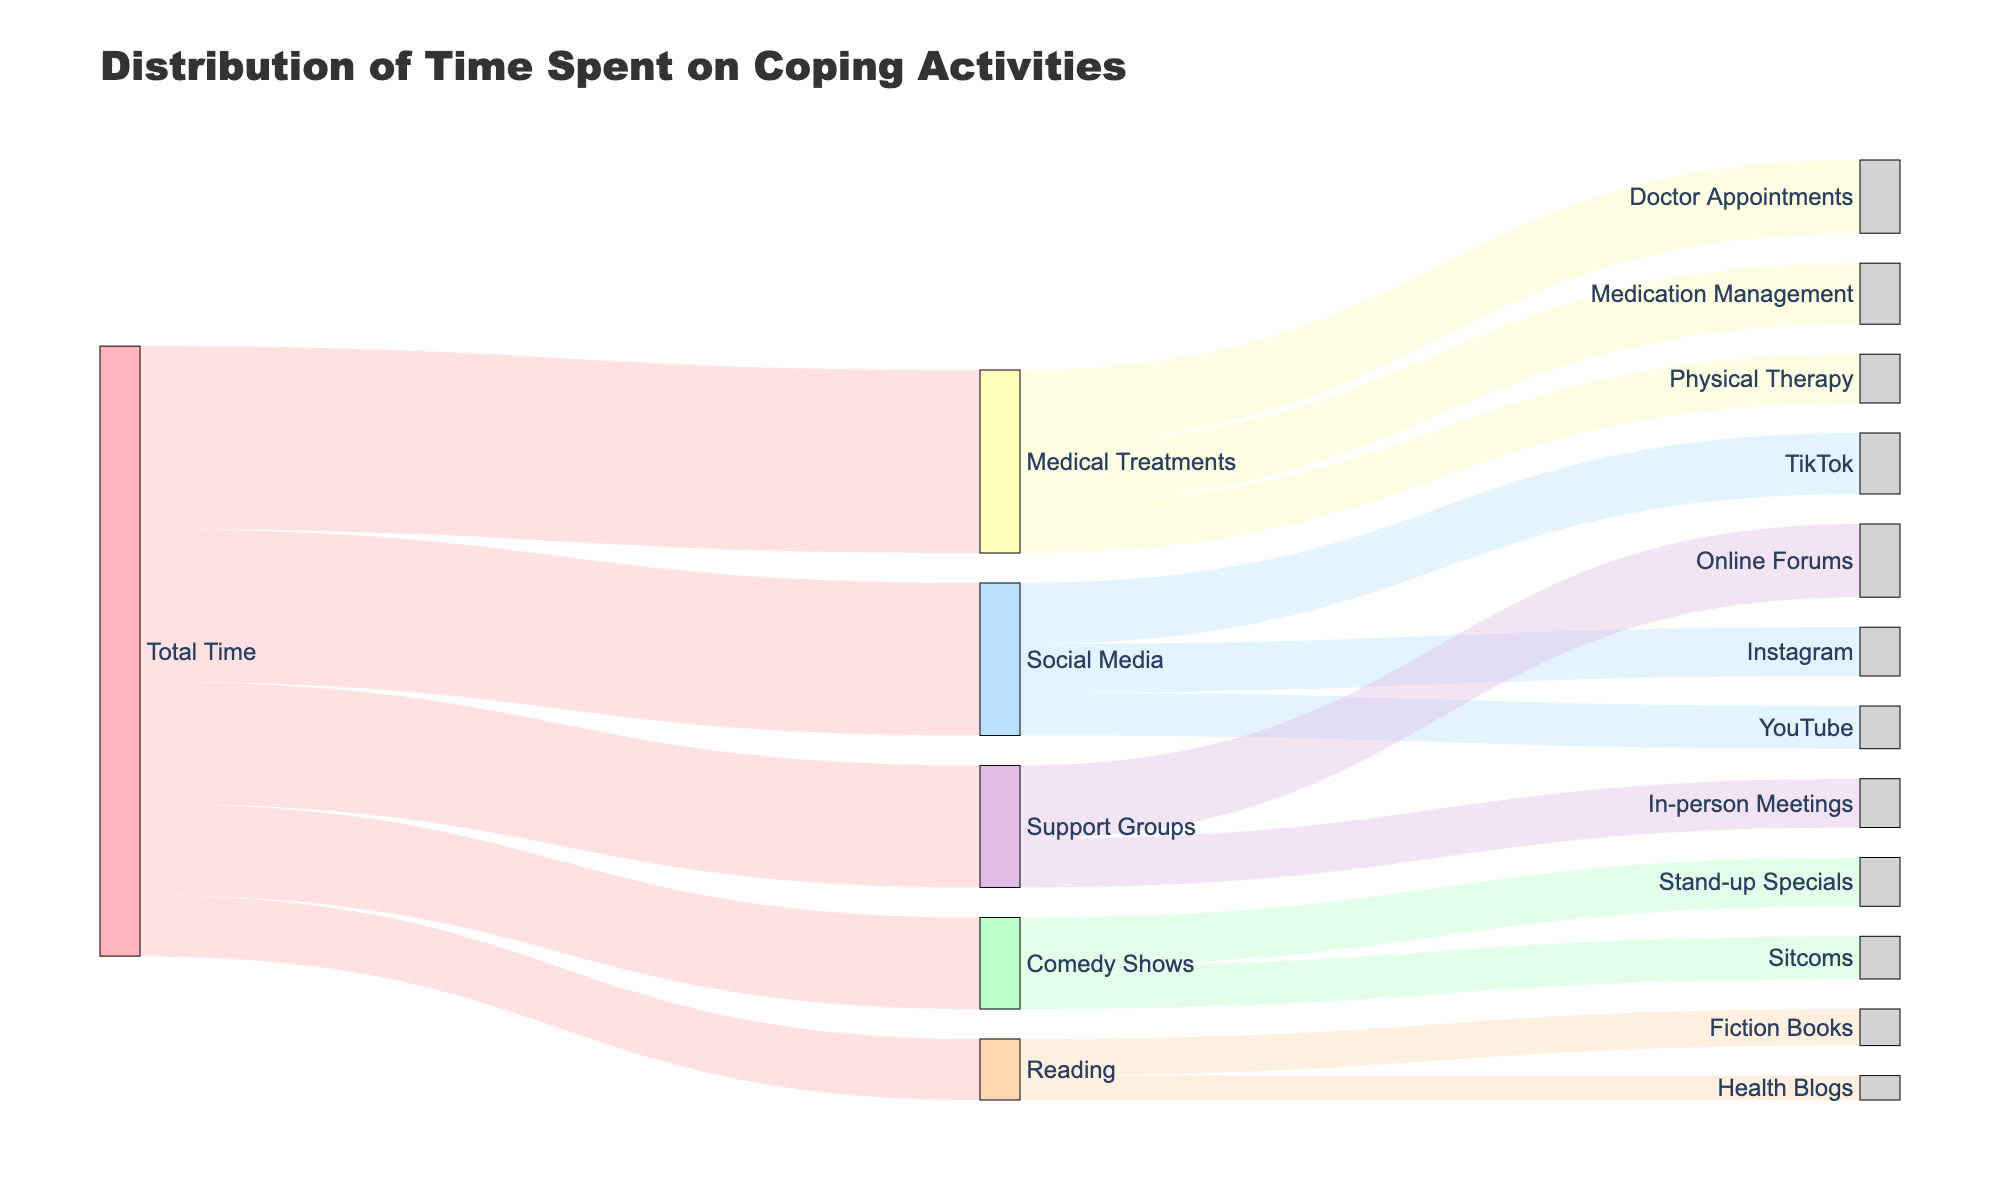What's the most significant coping activity by the total time spent? By observing the widest links from the "Total Time" node, we can determine the activity with the highest time allocation. The Medical Treatments link is the widest, indicating it receives the most time.
Answer: Medical Treatments How much time is spent on online platforms like TikTok and Instagram combined? To find this, locate the segments connecting Social Media to TikTok and Instagram. Adding their values, 10 for TikTok and 8 for Instagram, gives 18.
Answer: 18 Between Stand-up Specials and Sitcoms, which activity takes more time within Comedy Shows? By comparing the connections from Comedy Shows to Stand-up Specials and Sitcoms, we see that Stand-up Specials (8) has a slightly wider link than Sitcoms (7).
Answer: Stand-up Specials What proportion of the overall time is dedicated to Support Groups activities? Summing the values from Support Groups (Online Forums: 12 + In-person Meetings: 8) equals 20. Given the total time is 100, the proportion is 20 / 100 = 0.2 or 20%.
Answer: 20% How does time spent on Doctor Appointments compare to time spent on Physical Therapy? Locate Medical Treatments' links to Doctor Appointments (12) and Physical Therapy (8). Doctor Appointments' value is greater by 4.
Answer: Doctor Appointments has 4 more Which activity has the least total time dedicated to it? By reviewing all second-level connections in the diagram, the smallest value is Health Blogs under Reading, with 4.
Answer: Health Blogs What is the sum of time spent on Social Media and Reading? Adding the times allocated to Social Media (25) and Reading (10) gives a total of 35.
Answer: 35 Out of the nodes, which activity under Support Groups has more allocated time? Check the branches from Support Groups to Online Forums (12) and In-person Meetings (8). Online Forums has more.
Answer: Online Forums How much more time is spent on Medical Treatments compared to Comedy Shows? Medical Treatments has 30 units of time and Comedy Shows has 15; the difference is 30 - 15 = 15.
Answer: 15 